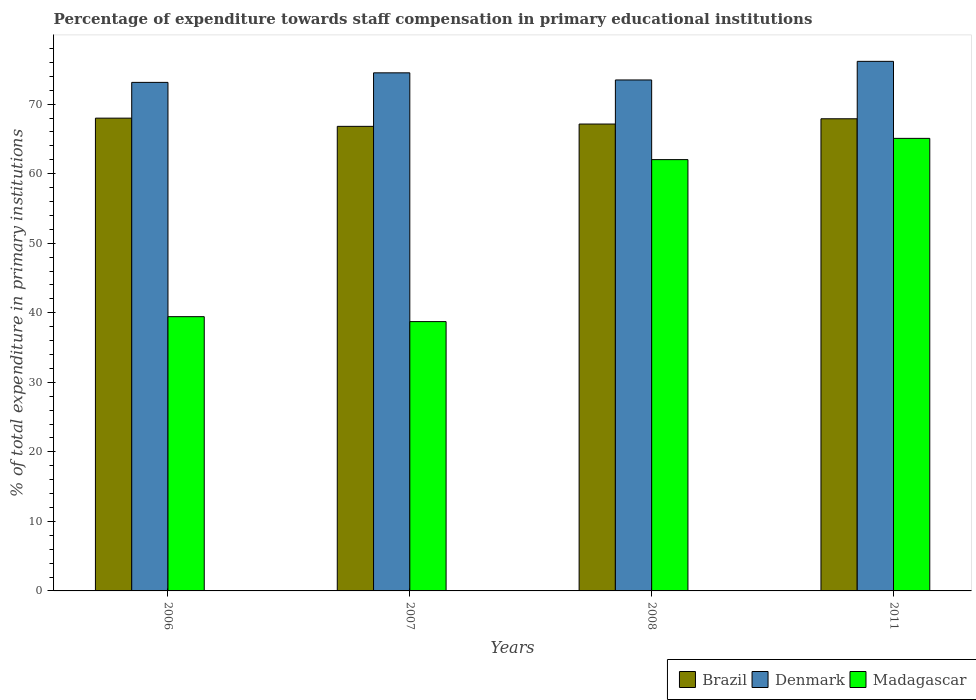How many groups of bars are there?
Your answer should be compact. 4. Are the number of bars on each tick of the X-axis equal?
Offer a very short reply. Yes. What is the label of the 3rd group of bars from the left?
Provide a succinct answer. 2008. What is the percentage of expenditure towards staff compensation in Brazil in 2011?
Your response must be concise. 67.89. Across all years, what is the maximum percentage of expenditure towards staff compensation in Brazil?
Offer a very short reply. 67.98. Across all years, what is the minimum percentage of expenditure towards staff compensation in Madagascar?
Offer a terse response. 38.72. In which year was the percentage of expenditure towards staff compensation in Madagascar maximum?
Offer a very short reply. 2011. In which year was the percentage of expenditure towards staff compensation in Madagascar minimum?
Ensure brevity in your answer.  2007. What is the total percentage of expenditure towards staff compensation in Denmark in the graph?
Your answer should be very brief. 297.23. What is the difference between the percentage of expenditure towards staff compensation in Denmark in 2008 and that in 2011?
Your response must be concise. -2.68. What is the difference between the percentage of expenditure towards staff compensation in Denmark in 2008 and the percentage of expenditure towards staff compensation in Brazil in 2006?
Your answer should be compact. 5.49. What is the average percentage of expenditure towards staff compensation in Madagascar per year?
Make the answer very short. 51.31. In the year 2007, what is the difference between the percentage of expenditure towards staff compensation in Brazil and percentage of expenditure towards staff compensation in Madagascar?
Offer a terse response. 28.08. In how many years, is the percentage of expenditure towards staff compensation in Brazil greater than 12 %?
Ensure brevity in your answer.  4. What is the ratio of the percentage of expenditure towards staff compensation in Brazil in 2006 to that in 2007?
Offer a very short reply. 1.02. Is the percentage of expenditure towards staff compensation in Denmark in 2007 less than that in 2008?
Ensure brevity in your answer.  No. Is the difference between the percentage of expenditure towards staff compensation in Brazil in 2007 and 2008 greater than the difference between the percentage of expenditure towards staff compensation in Madagascar in 2007 and 2008?
Offer a terse response. Yes. What is the difference between the highest and the second highest percentage of expenditure towards staff compensation in Brazil?
Offer a very short reply. 0.09. What is the difference between the highest and the lowest percentage of expenditure towards staff compensation in Brazil?
Make the answer very short. 1.18. In how many years, is the percentage of expenditure towards staff compensation in Denmark greater than the average percentage of expenditure towards staff compensation in Denmark taken over all years?
Offer a terse response. 2. What does the 2nd bar from the left in 2006 represents?
Ensure brevity in your answer.  Denmark. Is it the case that in every year, the sum of the percentage of expenditure towards staff compensation in Denmark and percentage of expenditure towards staff compensation in Madagascar is greater than the percentage of expenditure towards staff compensation in Brazil?
Your response must be concise. Yes. How many bars are there?
Provide a succinct answer. 12. How many years are there in the graph?
Ensure brevity in your answer.  4. What is the difference between two consecutive major ticks on the Y-axis?
Provide a short and direct response. 10. Does the graph contain any zero values?
Make the answer very short. No. Does the graph contain grids?
Offer a very short reply. No. What is the title of the graph?
Your response must be concise. Percentage of expenditure towards staff compensation in primary educational institutions. Does "Djibouti" appear as one of the legend labels in the graph?
Give a very brief answer. No. What is the label or title of the X-axis?
Give a very brief answer. Years. What is the label or title of the Y-axis?
Offer a terse response. % of total expenditure in primary institutions. What is the % of total expenditure in primary institutions of Brazil in 2006?
Your response must be concise. 67.98. What is the % of total expenditure in primary institutions in Denmark in 2006?
Offer a very short reply. 73.12. What is the % of total expenditure in primary institutions of Madagascar in 2006?
Keep it short and to the point. 39.44. What is the % of total expenditure in primary institutions of Brazil in 2007?
Your answer should be compact. 66.8. What is the % of total expenditure in primary institutions of Denmark in 2007?
Your answer should be very brief. 74.5. What is the % of total expenditure in primary institutions of Madagascar in 2007?
Ensure brevity in your answer.  38.72. What is the % of total expenditure in primary institutions of Brazil in 2008?
Provide a succinct answer. 67.13. What is the % of total expenditure in primary institutions in Denmark in 2008?
Offer a terse response. 73.47. What is the % of total expenditure in primary institutions of Madagascar in 2008?
Your answer should be compact. 62.02. What is the % of total expenditure in primary institutions in Brazil in 2011?
Ensure brevity in your answer.  67.89. What is the % of total expenditure in primary institutions in Denmark in 2011?
Your answer should be compact. 76.15. What is the % of total expenditure in primary institutions in Madagascar in 2011?
Offer a very short reply. 65.07. Across all years, what is the maximum % of total expenditure in primary institutions of Brazil?
Make the answer very short. 67.98. Across all years, what is the maximum % of total expenditure in primary institutions in Denmark?
Your answer should be very brief. 76.15. Across all years, what is the maximum % of total expenditure in primary institutions of Madagascar?
Make the answer very short. 65.07. Across all years, what is the minimum % of total expenditure in primary institutions of Brazil?
Offer a terse response. 66.8. Across all years, what is the minimum % of total expenditure in primary institutions in Denmark?
Keep it short and to the point. 73.12. Across all years, what is the minimum % of total expenditure in primary institutions of Madagascar?
Offer a terse response. 38.72. What is the total % of total expenditure in primary institutions of Brazil in the graph?
Your response must be concise. 269.8. What is the total % of total expenditure in primary institutions of Denmark in the graph?
Offer a terse response. 297.23. What is the total % of total expenditure in primary institutions in Madagascar in the graph?
Ensure brevity in your answer.  205.25. What is the difference between the % of total expenditure in primary institutions in Brazil in 2006 and that in 2007?
Make the answer very short. 1.18. What is the difference between the % of total expenditure in primary institutions in Denmark in 2006 and that in 2007?
Offer a terse response. -1.37. What is the difference between the % of total expenditure in primary institutions in Madagascar in 2006 and that in 2007?
Ensure brevity in your answer.  0.71. What is the difference between the % of total expenditure in primary institutions of Brazil in 2006 and that in 2008?
Your response must be concise. 0.85. What is the difference between the % of total expenditure in primary institutions in Denmark in 2006 and that in 2008?
Provide a succinct answer. -0.35. What is the difference between the % of total expenditure in primary institutions of Madagascar in 2006 and that in 2008?
Offer a very short reply. -22.58. What is the difference between the % of total expenditure in primary institutions in Brazil in 2006 and that in 2011?
Provide a short and direct response. 0.09. What is the difference between the % of total expenditure in primary institutions of Denmark in 2006 and that in 2011?
Your answer should be very brief. -3.02. What is the difference between the % of total expenditure in primary institutions in Madagascar in 2006 and that in 2011?
Provide a succinct answer. -25.64. What is the difference between the % of total expenditure in primary institutions in Brazil in 2007 and that in 2008?
Offer a terse response. -0.33. What is the difference between the % of total expenditure in primary institutions of Denmark in 2007 and that in 2008?
Provide a succinct answer. 1.03. What is the difference between the % of total expenditure in primary institutions of Madagascar in 2007 and that in 2008?
Your response must be concise. -23.29. What is the difference between the % of total expenditure in primary institutions in Brazil in 2007 and that in 2011?
Keep it short and to the point. -1.09. What is the difference between the % of total expenditure in primary institutions in Denmark in 2007 and that in 2011?
Keep it short and to the point. -1.65. What is the difference between the % of total expenditure in primary institutions in Madagascar in 2007 and that in 2011?
Provide a short and direct response. -26.35. What is the difference between the % of total expenditure in primary institutions of Brazil in 2008 and that in 2011?
Give a very brief answer. -0.76. What is the difference between the % of total expenditure in primary institutions in Denmark in 2008 and that in 2011?
Make the answer very short. -2.68. What is the difference between the % of total expenditure in primary institutions in Madagascar in 2008 and that in 2011?
Keep it short and to the point. -3.06. What is the difference between the % of total expenditure in primary institutions of Brazil in 2006 and the % of total expenditure in primary institutions of Denmark in 2007?
Your response must be concise. -6.52. What is the difference between the % of total expenditure in primary institutions in Brazil in 2006 and the % of total expenditure in primary institutions in Madagascar in 2007?
Your answer should be compact. 29.25. What is the difference between the % of total expenditure in primary institutions of Denmark in 2006 and the % of total expenditure in primary institutions of Madagascar in 2007?
Your answer should be very brief. 34.4. What is the difference between the % of total expenditure in primary institutions of Brazil in 2006 and the % of total expenditure in primary institutions of Denmark in 2008?
Make the answer very short. -5.49. What is the difference between the % of total expenditure in primary institutions in Brazil in 2006 and the % of total expenditure in primary institutions in Madagascar in 2008?
Give a very brief answer. 5.96. What is the difference between the % of total expenditure in primary institutions of Denmark in 2006 and the % of total expenditure in primary institutions of Madagascar in 2008?
Provide a succinct answer. 11.11. What is the difference between the % of total expenditure in primary institutions in Brazil in 2006 and the % of total expenditure in primary institutions in Denmark in 2011?
Your answer should be compact. -8.17. What is the difference between the % of total expenditure in primary institutions in Brazil in 2006 and the % of total expenditure in primary institutions in Madagascar in 2011?
Keep it short and to the point. 2.91. What is the difference between the % of total expenditure in primary institutions of Denmark in 2006 and the % of total expenditure in primary institutions of Madagascar in 2011?
Provide a succinct answer. 8.05. What is the difference between the % of total expenditure in primary institutions in Brazil in 2007 and the % of total expenditure in primary institutions in Denmark in 2008?
Keep it short and to the point. -6.67. What is the difference between the % of total expenditure in primary institutions of Brazil in 2007 and the % of total expenditure in primary institutions of Madagascar in 2008?
Your answer should be very brief. 4.78. What is the difference between the % of total expenditure in primary institutions in Denmark in 2007 and the % of total expenditure in primary institutions in Madagascar in 2008?
Offer a terse response. 12.48. What is the difference between the % of total expenditure in primary institutions in Brazil in 2007 and the % of total expenditure in primary institutions in Denmark in 2011?
Provide a short and direct response. -9.35. What is the difference between the % of total expenditure in primary institutions in Brazil in 2007 and the % of total expenditure in primary institutions in Madagascar in 2011?
Provide a short and direct response. 1.73. What is the difference between the % of total expenditure in primary institutions in Denmark in 2007 and the % of total expenditure in primary institutions in Madagascar in 2011?
Your answer should be compact. 9.42. What is the difference between the % of total expenditure in primary institutions in Brazil in 2008 and the % of total expenditure in primary institutions in Denmark in 2011?
Provide a short and direct response. -9.01. What is the difference between the % of total expenditure in primary institutions in Brazil in 2008 and the % of total expenditure in primary institutions in Madagascar in 2011?
Provide a short and direct response. 2.06. What is the difference between the % of total expenditure in primary institutions of Denmark in 2008 and the % of total expenditure in primary institutions of Madagascar in 2011?
Your answer should be very brief. 8.4. What is the average % of total expenditure in primary institutions of Brazil per year?
Keep it short and to the point. 67.45. What is the average % of total expenditure in primary institutions of Denmark per year?
Give a very brief answer. 74.31. What is the average % of total expenditure in primary institutions of Madagascar per year?
Offer a terse response. 51.31. In the year 2006, what is the difference between the % of total expenditure in primary institutions in Brazil and % of total expenditure in primary institutions in Denmark?
Give a very brief answer. -5.14. In the year 2006, what is the difference between the % of total expenditure in primary institutions in Brazil and % of total expenditure in primary institutions in Madagascar?
Give a very brief answer. 28.54. In the year 2006, what is the difference between the % of total expenditure in primary institutions in Denmark and % of total expenditure in primary institutions in Madagascar?
Offer a very short reply. 33.69. In the year 2007, what is the difference between the % of total expenditure in primary institutions of Brazil and % of total expenditure in primary institutions of Denmark?
Provide a short and direct response. -7.7. In the year 2007, what is the difference between the % of total expenditure in primary institutions in Brazil and % of total expenditure in primary institutions in Madagascar?
Give a very brief answer. 28.08. In the year 2007, what is the difference between the % of total expenditure in primary institutions in Denmark and % of total expenditure in primary institutions in Madagascar?
Keep it short and to the point. 35.77. In the year 2008, what is the difference between the % of total expenditure in primary institutions in Brazil and % of total expenditure in primary institutions in Denmark?
Your answer should be very brief. -6.34. In the year 2008, what is the difference between the % of total expenditure in primary institutions in Brazil and % of total expenditure in primary institutions in Madagascar?
Provide a succinct answer. 5.12. In the year 2008, what is the difference between the % of total expenditure in primary institutions of Denmark and % of total expenditure in primary institutions of Madagascar?
Keep it short and to the point. 11.45. In the year 2011, what is the difference between the % of total expenditure in primary institutions in Brazil and % of total expenditure in primary institutions in Denmark?
Your answer should be compact. -8.26. In the year 2011, what is the difference between the % of total expenditure in primary institutions of Brazil and % of total expenditure in primary institutions of Madagascar?
Your answer should be very brief. 2.82. In the year 2011, what is the difference between the % of total expenditure in primary institutions of Denmark and % of total expenditure in primary institutions of Madagascar?
Your answer should be compact. 11.07. What is the ratio of the % of total expenditure in primary institutions in Brazil in 2006 to that in 2007?
Your answer should be compact. 1.02. What is the ratio of the % of total expenditure in primary institutions of Denmark in 2006 to that in 2007?
Your answer should be very brief. 0.98. What is the ratio of the % of total expenditure in primary institutions in Madagascar in 2006 to that in 2007?
Your response must be concise. 1.02. What is the ratio of the % of total expenditure in primary institutions of Brazil in 2006 to that in 2008?
Ensure brevity in your answer.  1.01. What is the ratio of the % of total expenditure in primary institutions of Madagascar in 2006 to that in 2008?
Provide a short and direct response. 0.64. What is the ratio of the % of total expenditure in primary institutions of Denmark in 2006 to that in 2011?
Make the answer very short. 0.96. What is the ratio of the % of total expenditure in primary institutions in Madagascar in 2006 to that in 2011?
Your response must be concise. 0.61. What is the ratio of the % of total expenditure in primary institutions of Brazil in 2007 to that in 2008?
Your answer should be very brief. 0.99. What is the ratio of the % of total expenditure in primary institutions of Denmark in 2007 to that in 2008?
Give a very brief answer. 1.01. What is the ratio of the % of total expenditure in primary institutions in Madagascar in 2007 to that in 2008?
Provide a succinct answer. 0.62. What is the ratio of the % of total expenditure in primary institutions of Brazil in 2007 to that in 2011?
Give a very brief answer. 0.98. What is the ratio of the % of total expenditure in primary institutions in Denmark in 2007 to that in 2011?
Your answer should be compact. 0.98. What is the ratio of the % of total expenditure in primary institutions of Madagascar in 2007 to that in 2011?
Give a very brief answer. 0.6. What is the ratio of the % of total expenditure in primary institutions in Denmark in 2008 to that in 2011?
Make the answer very short. 0.96. What is the ratio of the % of total expenditure in primary institutions in Madagascar in 2008 to that in 2011?
Provide a succinct answer. 0.95. What is the difference between the highest and the second highest % of total expenditure in primary institutions of Brazil?
Give a very brief answer. 0.09. What is the difference between the highest and the second highest % of total expenditure in primary institutions of Denmark?
Your answer should be compact. 1.65. What is the difference between the highest and the second highest % of total expenditure in primary institutions in Madagascar?
Provide a short and direct response. 3.06. What is the difference between the highest and the lowest % of total expenditure in primary institutions of Brazil?
Offer a very short reply. 1.18. What is the difference between the highest and the lowest % of total expenditure in primary institutions in Denmark?
Ensure brevity in your answer.  3.02. What is the difference between the highest and the lowest % of total expenditure in primary institutions in Madagascar?
Give a very brief answer. 26.35. 